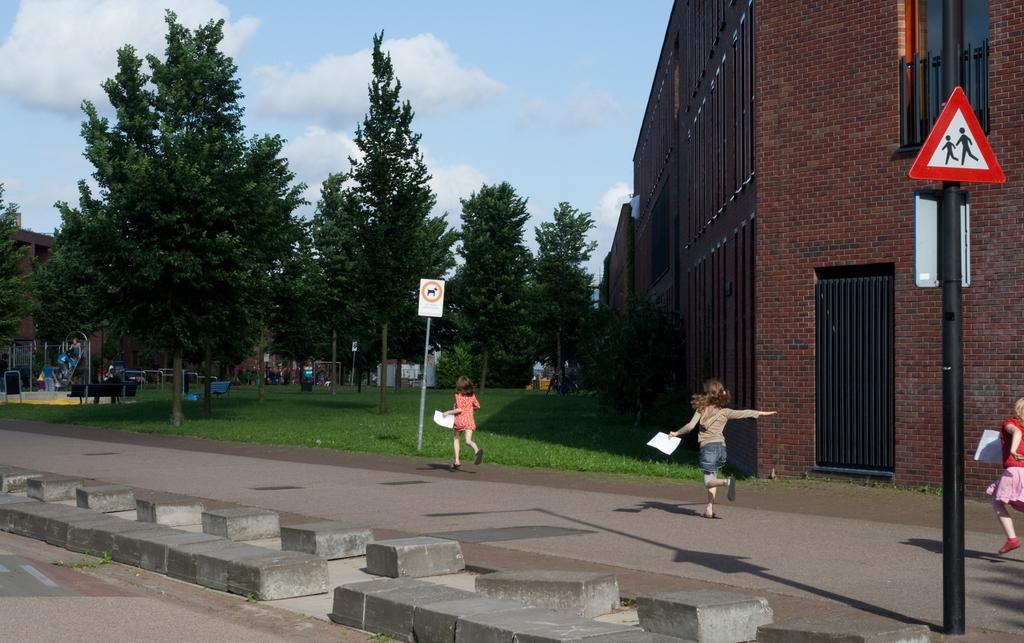Could you give a brief overview of what you see in this image? In this image we can see a few buildings, there are some trees, persons, lights, boards, stones, benches and some other objects on the ground, in the background we can see the sky with clouds. 